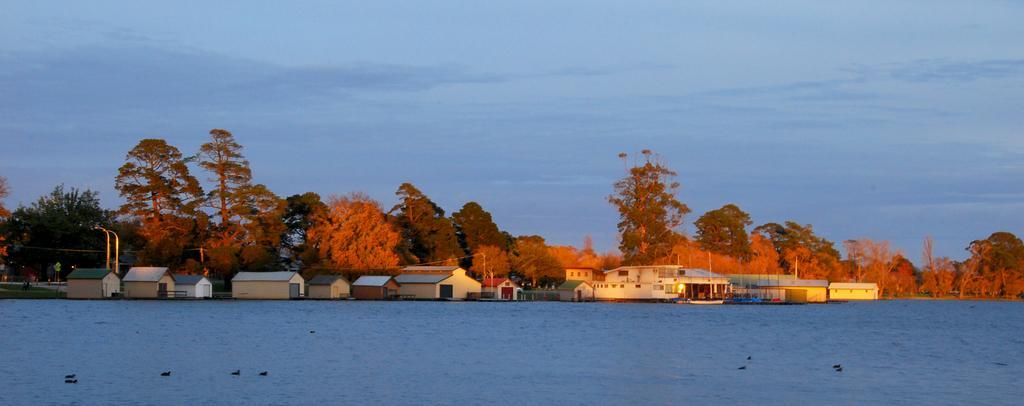How would you summarize this image in a sentence or two? In this image we can see some houses, there are trees, poles, there are a few persons, also we can see the sky, and some birds are in the lake. 